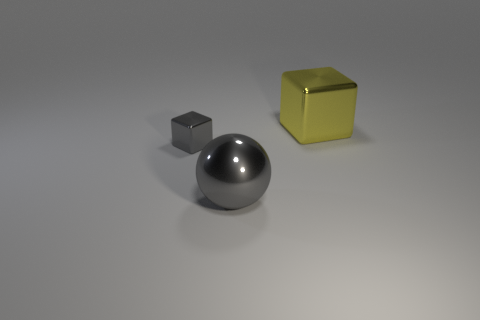Subtract all blue spheres. Subtract all gray cylinders. How many spheres are left? 1 Add 2 small shiny things. How many objects exist? 5 Subtract all balls. How many objects are left? 2 Subtract 0 brown spheres. How many objects are left? 3 Subtract all big yellow metallic things. Subtract all green matte blocks. How many objects are left? 2 Add 1 large cubes. How many large cubes are left? 2 Add 1 big gray spheres. How many big gray spheres exist? 2 